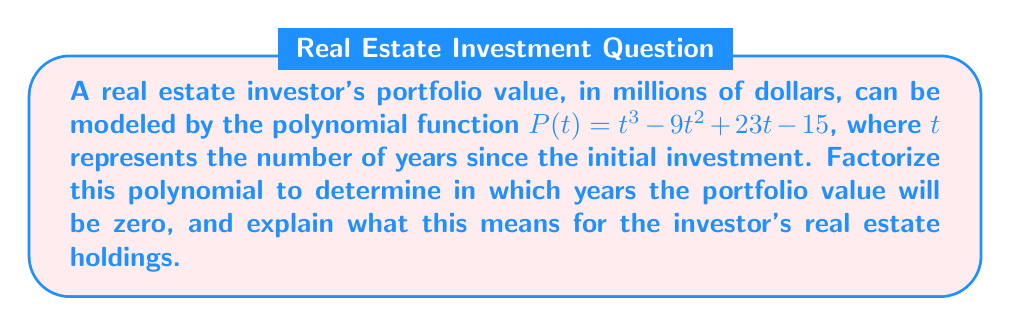Help me with this question. To solve this problem, we need to factorize the polynomial $P(t) = t^3 - 9t^2 + 23t - 15$. We'll use the following steps:

1) First, let's check if there's a common factor. There isn't, so we proceed to the next step.

2) We'll try to guess one root. After some trial and error, we find that $t = 1$ is a root.

3) We can now use polynomial long division to divide $P(t)$ by $(t - 1)$:

   $$t^3 - 9t^2 + 23t - 15 = (t - 1)(t^2 - 8t + 15)$$

4) Now we need to factorize the quadratic $t^2 - 8t + 15$. We can do this by finding two numbers that multiply to give 15 and add to give -8. These numbers are -3 and -5.

5) Therefore, our complete factorization is:

   $$P(t) = (t - 1)(t - 3)(t - 5)$$

6) The roots of this polynomial are $t = 1$, $t = 3$, and $t = 5$.

For a real estate investor, this means:

- The portfolio value will be zero after 1 year, 3 years, and 5 years from the initial investment.
- Between these points, the portfolio value will be positive (above the t-axis) or negative (below the t-axis).
- Specifically, the value will be positive from 0 to 1 year, negative from 1 to 3 years, positive from 3 to 5 years, and positive after 5 years.

This fluctuation could represent market cycles or the impact of leveraged investments. The investor should be prepared for periods of negative equity but can expect long-term growth beyond the 5-year mark.
Answer: The portfolio value will be zero at $t = 1$, $t = 3$, and $t = 5$ years. The factored form of the polynomial is $P(t) = (t - 1)(t - 3)(t - 5)$. 